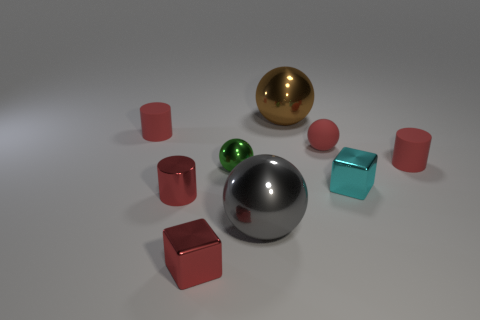Are there any other large gray things that have the same shape as the large gray object?
Offer a very short reply. No. Is the size of the red cylinder that is on the right side of the brown shiny object the same as the cylinder in front of the cyan block?
Provide a succinct answer. Yes. Are there more tiny red matte cylinders than cyan shiny blocks?
Keep it short and to the point. Yes. What number of cylinders have the same material as the red ball?
Provide a short and direct response. 2. Is the brown metallic object the same shape as the green metal thing?
Give a very brief answer. Yes. What size is the red matte cylinder to the left of the tiny red rubber cylinder to the right of the tiny red cylinder behind the tiny red rubber ball?
Your answer should be very brief. Small. Are there any red objects in front of the large object in front of the tiny green metal thing?
Give a very brief answer. Yes. What number of tiny blocks are in front of the big ball in front of the red matte object that is left of the small red metal cube?
Ensure brevity in your answer.  1. There is a ball that is behind the tiny metal ball and in front of the big brown metal object; what color is it?
Give a very brief answer. Red. How many tiny metal cubes have the same color as the shiny cylinder?
Your answer should be compact. 1. 